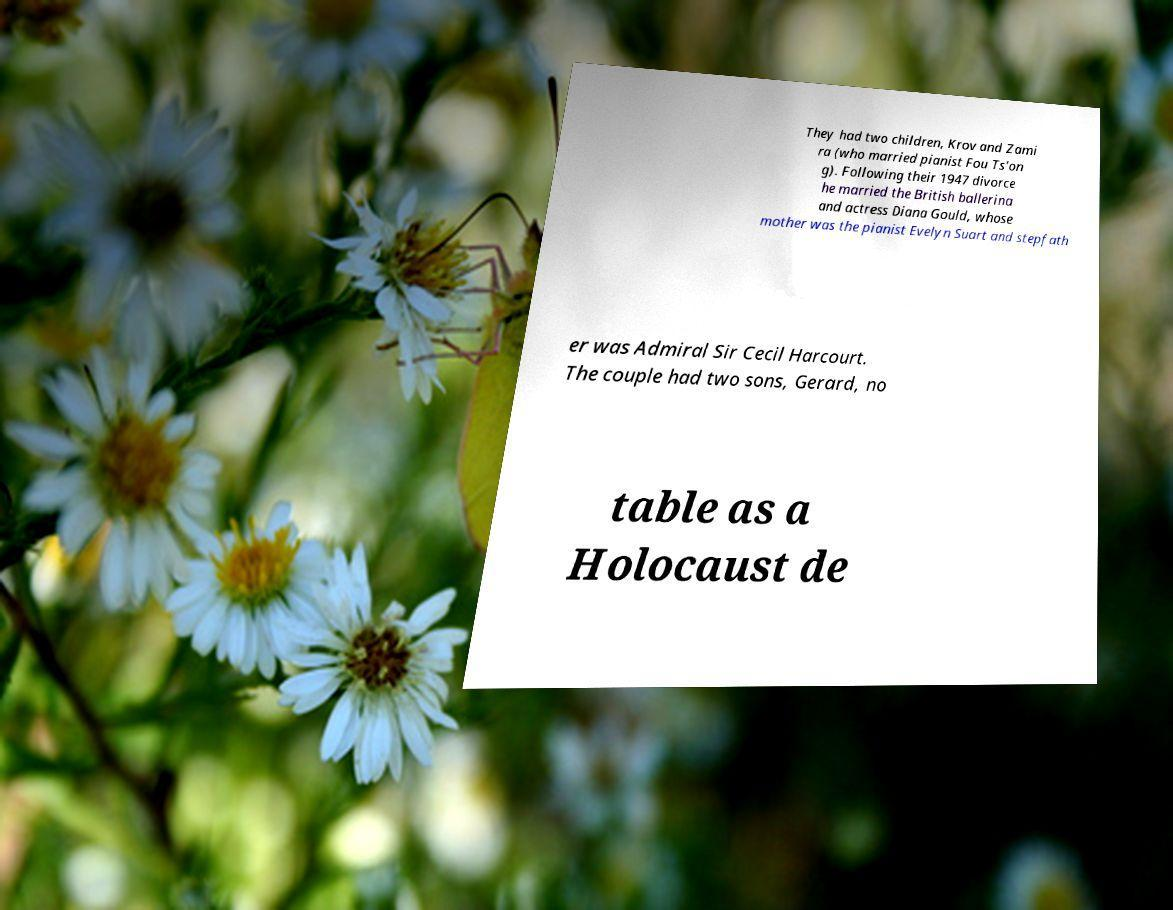Please read and relay the text visible in this image. What does it say? They had two children, Krov and Zami ra (who married pianist Fou Ts'on g). Following their 1947 divorce he married the British ballerina and actress Diana Gould, whose mother was the pianist Evelyn Suart and stepfath er was Admiral Sir Cecil Harcourt. The couple had two sons, Gerard, no table as a Holocaust de 